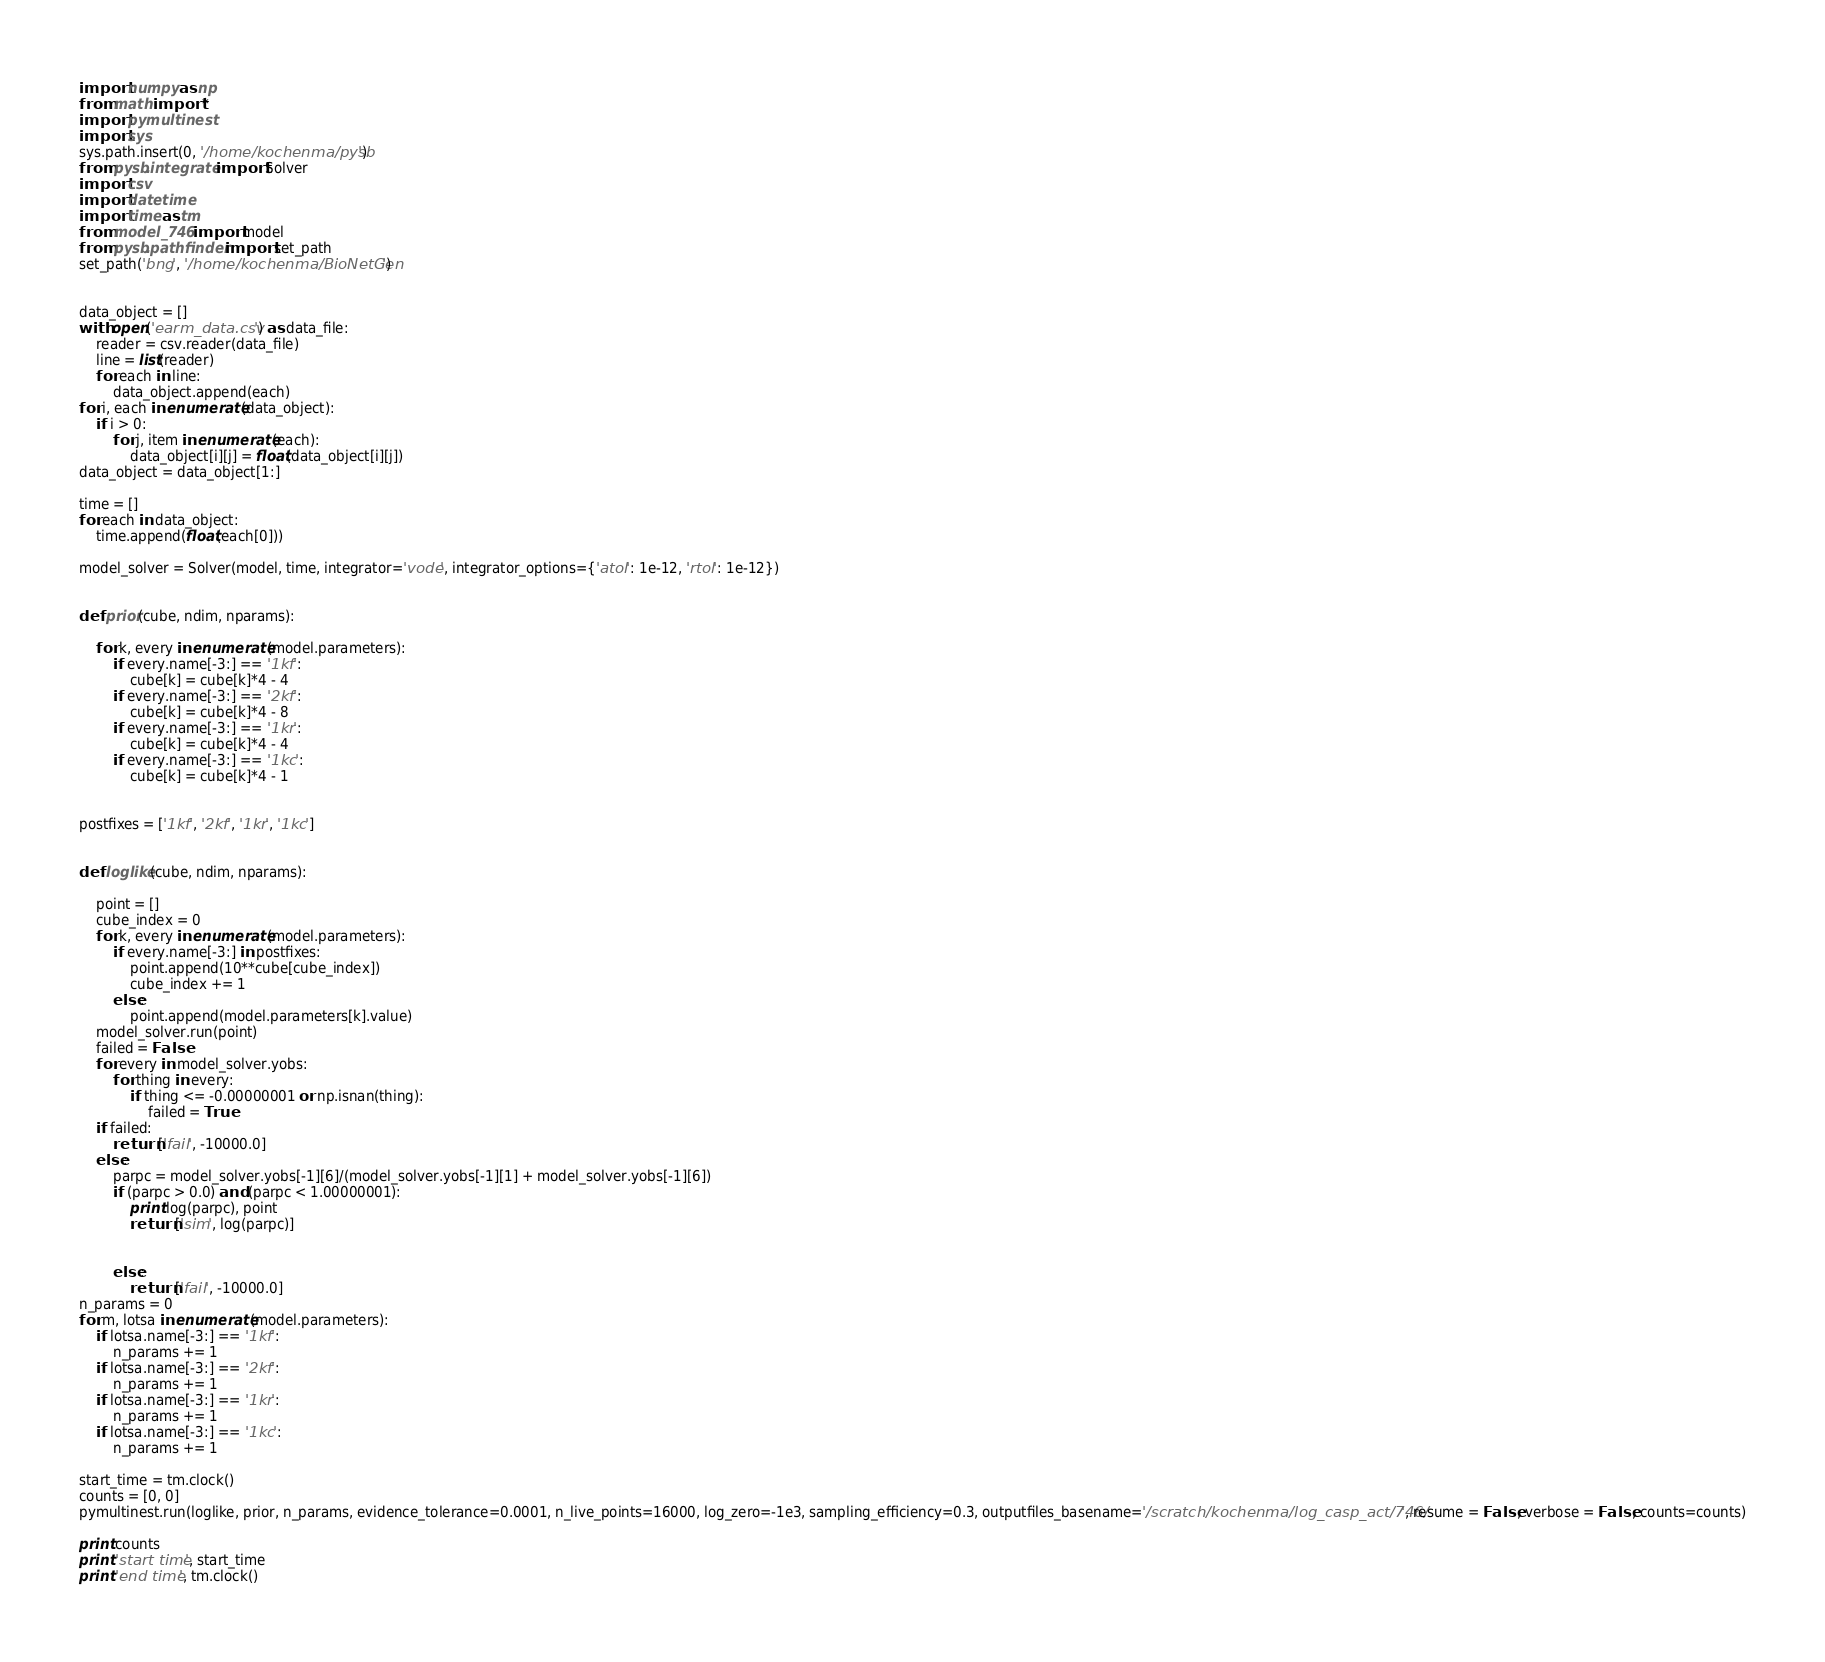Convert code to text. <code><loc_0><loc_0><loc_500><loc_500><_Python_>
import numpy as np
from math import *
import pymultinest
import sys
sys.path.insert(0, '/home/kochenma/pysb')
from pysb.integrate import Solver
import csv
import datetime
import time as tm
from model_746 import model
from pysb.pathfinder import set_path
set_path('bng', '/home/kochenma/BioNetGen')


data_object = []
with open('earm_data.csv') as data_file:
	reader = csv.reader(data_file)
	line = list(reader)
	for each in line:
		data_object.append(each)
for i, each in enumerate(data_object):
	if i > 0:
		for j, item in enumerate(each):
			data_object[i][j] = float(data_object[i][j])
data_object = data_object[1:]

time = []
for each in data_object:
	time.append(float(each[0]))

model_solver = Solver(model, time, integrator='vode', integrator_options={'atol': 1e-12, 'rtol': 1e-12})


def prior(cube, ndim, nparams):

	for k, every in enumerate(model.parameters):
		if every.name[-3:] == '1kf':
			cube[k] = cube[k]*4 - 4
		if every.name[-3:] == '2kf':
			cube[k] = cube[k]*4 - 8
		if every.name[-3:] == '1kr':
			cube[k] = cube[k]*4 - 4
		if every.name[-3:] == '1kc':
			cube[k] = cube[k]*4 - 1


postfixes = ['1kf', '2kf', '1kr', '1kc']


def loglike(cube, ndim, nparams):

	point = []
	cube_index = 0
	for k, every in enumerate(model.parameters):
		if every.name[-3:] in postfixes:
			point.append(10**cube[cube_index])
			cube_index += 1
		else:
			point.append(model.parameters[k].value)
	model_solver.run(point)
	failed = False
	for every in model_solver.yobs:
		for thing in every:
			if thing <= -0.00000001 or np.isnan(thing):
				failed = True
	if failed:
		return ['fail', -10000.0]
	else:
		parpc = model_solver.yobs[-1][6]/(model_solver.yobs[-1][1] + model_solver.yobs[-1][6])
		if (parpc > 0.0) and (parpc < 1.00000001):
			print log(parpc), point
			return ['sim', log(parpc)]


		else:
			return ['fail', -10000.0]
n_params = 0
for m, lotsa in enumerate(model.parameters):
	if lotsa.name[-3:] == '1kf':
		n_params += 1
	if lotsa.name[-3:] == '2kf':
		n_params += 1
	if lotsa.name[-3:] == '1kr':
		n_params += 1
	if lotsa.name[-3:] == '1kc':
		n_params += 1

start_time = tm.clock()
counts = [0, 0]
pymultinest.run(loglike, prior, n_params, evidence_tolerance=0.0001, n_live_points=16000, log_zero=-1e3, sampling_efficiency=0.3, outputfiles_basename='/scratch/kochenma/log_casp_act/746/', resume = False, verbose = False, counts=counts)

print counts
print 'start time', start_time
print 'end time', tm.clock()</code> 